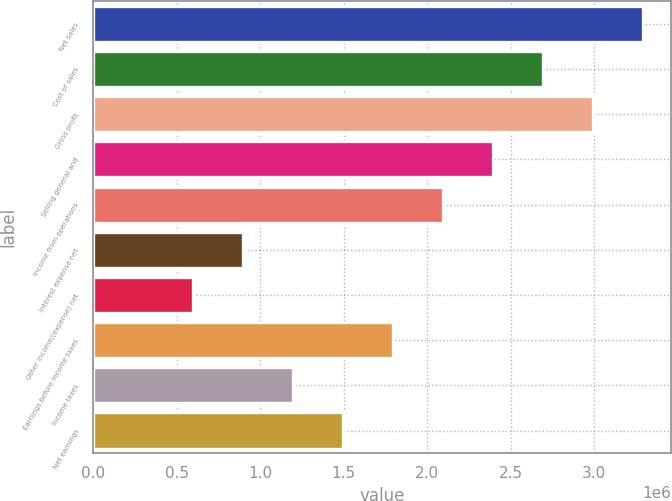Convert chart to OTSL. <chart><loc_0><loc_0><loc_500><loc_500><bar_chart><fcel>Net sales<fcel>Cost of sales<fcel>Gross profit<fcel>Selling general and<fcel>Income from operations<fcel>Interest expense net<fcel>Other income/(expense) net<fcel>Earnings before income taxes<fcel>Income taxes<fcel>Net earnings<nl><fcel>3.29284e+06<fcel>2.69414e+06<fcel>2.99349e+06<fcel>2.39479e+06<fcel>2.09544e+06<fcel>898050<fcel>598702<fcel>1.7961e+06<fcel>1.1974e+06<fcel>1.49675e+06<nl></chart> 